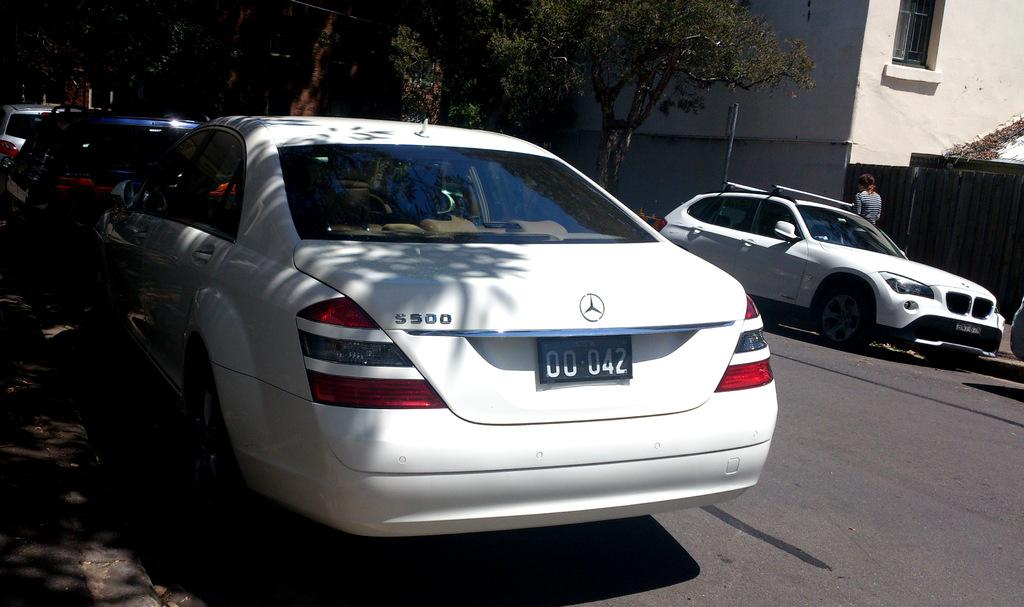What can be seen on the road in the image? There are vehicles on the road in the image. Where is the person located in the image? The person is standing on the right side of the image. What can be seen in the distance in the image? There are trees and a building visible in the background of the image. How many dolls are sitting on the feather in the image? There are no dolls or feathers present in the image. What is the value of the item being sold in the image? There is no item being sold in the image, so it is not possible to determine its value. 